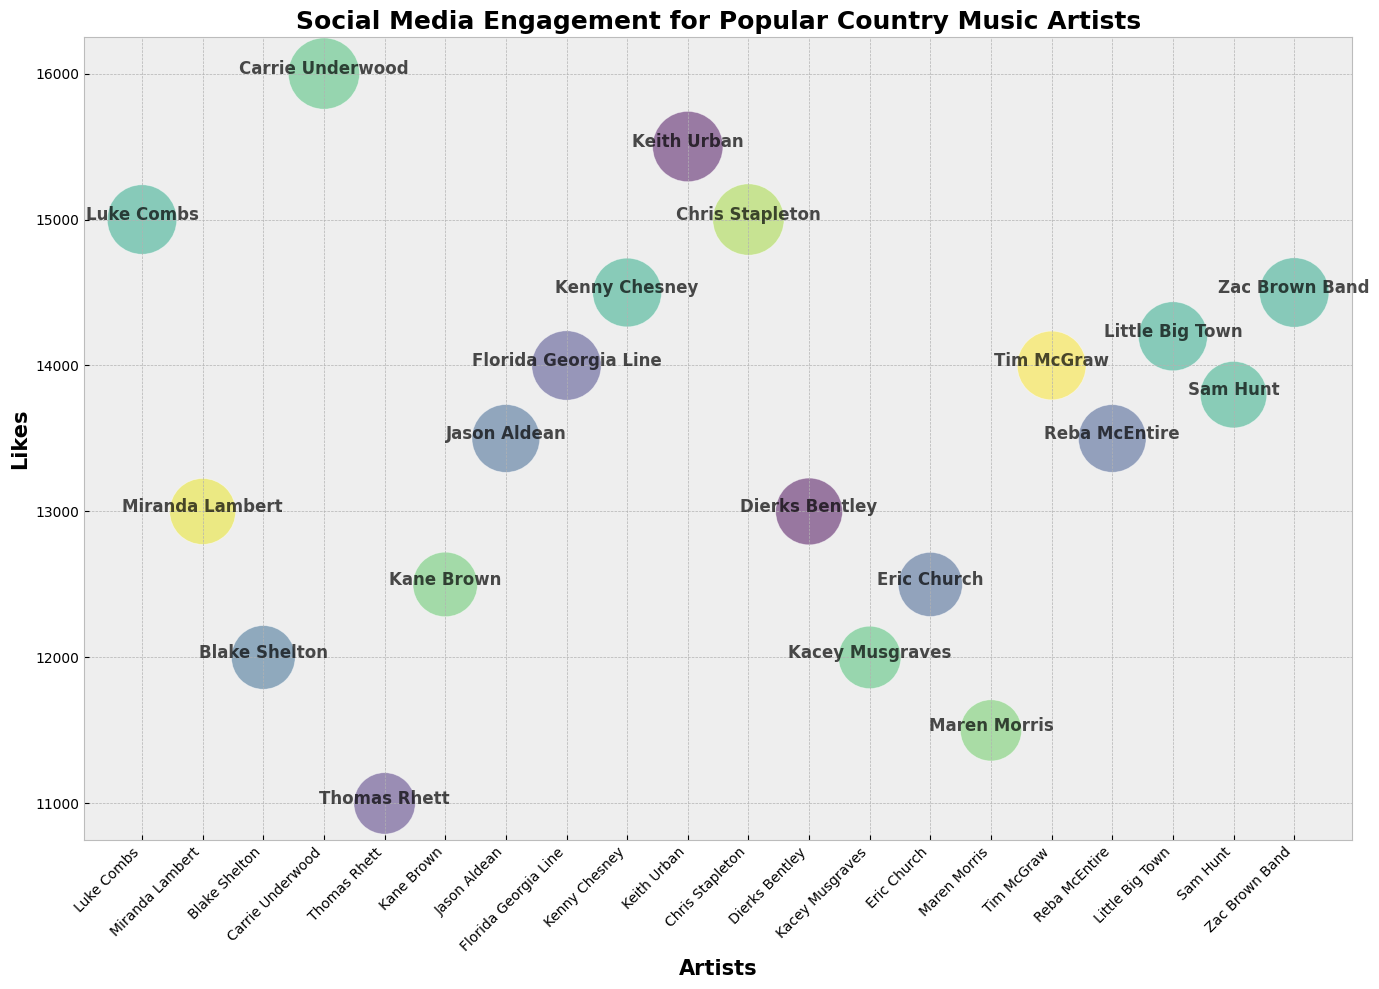Which artist has the highest number of likes? From the figure, the y-axis shows the number of likes. By looking at the highest point on the y-axis, we see that Carrie Underwood has the highest number of likes.
Answer: Carrie Underwood Which artist has the smallest bubble size, and what could that indicate? Bubble size represents the sum of shares and comments. The smallest bubble indicates the lowest sum. By observing the bubbles, Maren Morris has the smallest one, suggesting she has the fewest shares plus comments.
Answer: Maren Morris Who received more likes, Keith Urban or Kenny Chesney? Keith Urban's bubble is positioned higher on the y-axis compared to Kenny Chesney, indicating that Keith Urban has more likes.
Answer: Keith Urban Which artist has more engagement: Florida Georgia Line or Miranda Lambert? Engagement is represented by both the y-axis (likes) and bubble size (shares + comments). Florida Georgia Line has both a higher position on the y-axis and a larger bubble size compared to Miranda Lambert, indicating more engagement.
Answer: Florida Georgia Line Compare the bubble size of Chris Stapleton and Luke Combs. Who has a larger bubble and why? Bubble size denotes the sum of shares and comments. Chris Stapleton's bubble appears larger than Luke Combs', meaning his total shares plus comments are higher.
Answer: Chris Stapleton Which artist has an average of 13,500 likes and a bubble size of around 2,380? Find the artist positioned around 13,500 on the y-axis with a corresponding bubble size. Jason Aldean fits this profile with around 13,500 likes and a sum of shares and comments close to 2,380.
Answer: Jason Aldean What is the general trend between likes and bubble size? By visual inspection, there is no clear trend between the height of the bubbles (likes) and their sizes (shares + comments), as some high likes artists have variable bubble sizes and vice versa.
Answer: No clear trend Which artist has a higher engagement, considering both likes and bubble size, Chris Stapleton or Zac Brown Band? By comparing both likes (y-axis position) and bubble size, Chris Stapleton is slightly higher in likes and has a larger bubble than Zac Brown Band, suggesting higher engagement.
Answer: Chris Stapleton 